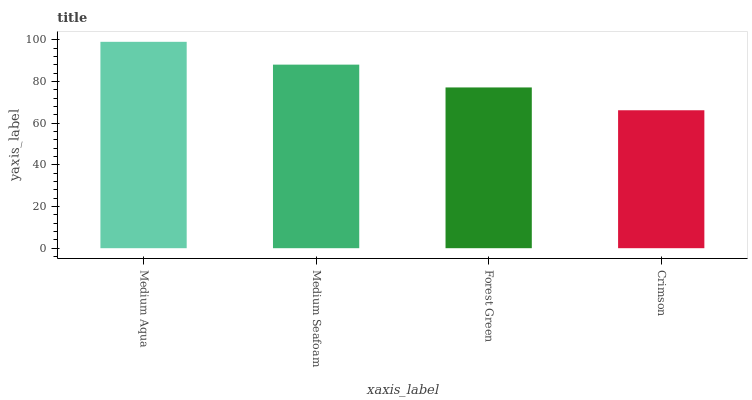Is Crimson the minimum?
Answer yes or no. Yes. Is Medium Aqua the maximum?
Answer yes or no. Yes. Is Medium Seafoam the minimum?
Answer yes or no. No. Is Medium Seafoam the maximum?
Answer yes or no. No. Is Medium Aqua greater than Medium Seafoam?
Answer yes or no. Yes. Is Medium Seafoam less than Medium Aqua?
Answer yes or no. Yes. Is Medium Seafoam greater than Medium Aqua?
Answer yes or no. No. Is Medium Aqua less than Medium Seafoam?
Answer yes or no. No. Is Medium Seafoam the high median?
Answer yes or no. Yes. Is Forest Green the low median?
Answer yes or no. Yes. Is Forest Green the high median?
Answer yes or no. No. Is Medium Aqua the low median?
Answer yes or no. No. 